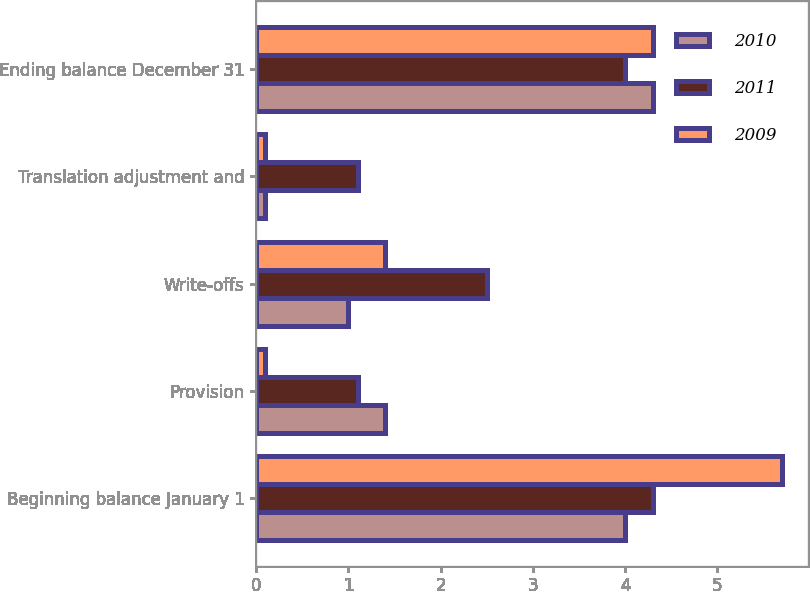<chart> <loc_0><loc_0><loc_500><loc_500><stacked_bar_chart><ecel><fcel>Beginning balance January 1<fcel>Provision<fcel>Write-offs<fcel>Translation adjustment and<fcel>Ending balance December 31<nl><fcel>2010<fcel>4<fcel>1.4<fcel>1<fcel>0.1<fcel>4.3<nl><fcel>2011<fcel>4.3<fcel>1.1<fcel>2.5<fcel>1.1<fcel>4<nl><fcel>2009<fcel>5.7<fcel>0.1<fcel>1.4<fcel>0.1<fcel>4.3<nl></chart> 